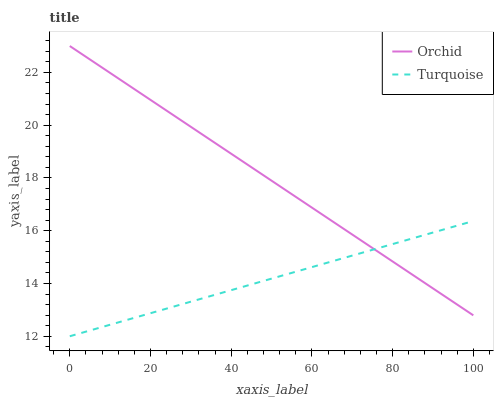Does Turquoise have the minimum area under the curve?
Answer yes or no. Yes. Does Orchid have the maximum area under the curve?
Answer yes or no. Yes. Does Orchid have the minimum area under the curve?
Answer yes or no. No. Is Orchid the smoothest?
Answer yes or no. Yes. Is Turquoise the roughest?
Answer yes or no. Yes. Is Orchid the roughest?
Answer yes or no. No. Does Turquoise have the lowest value?
Answer yes or no. Yes. Does Orchid have the lowest value?
Answer yes or no. No. Does Orchid have the highest value?
Answer yes or no. Yes. Does Turquoise intersect Orchid?
Answer yes or no. Yes. Is Turquoise less than Orchid?
Answer yes or no. No. Is Turquoise greater than Orchid?
Answer yes or no. No. 